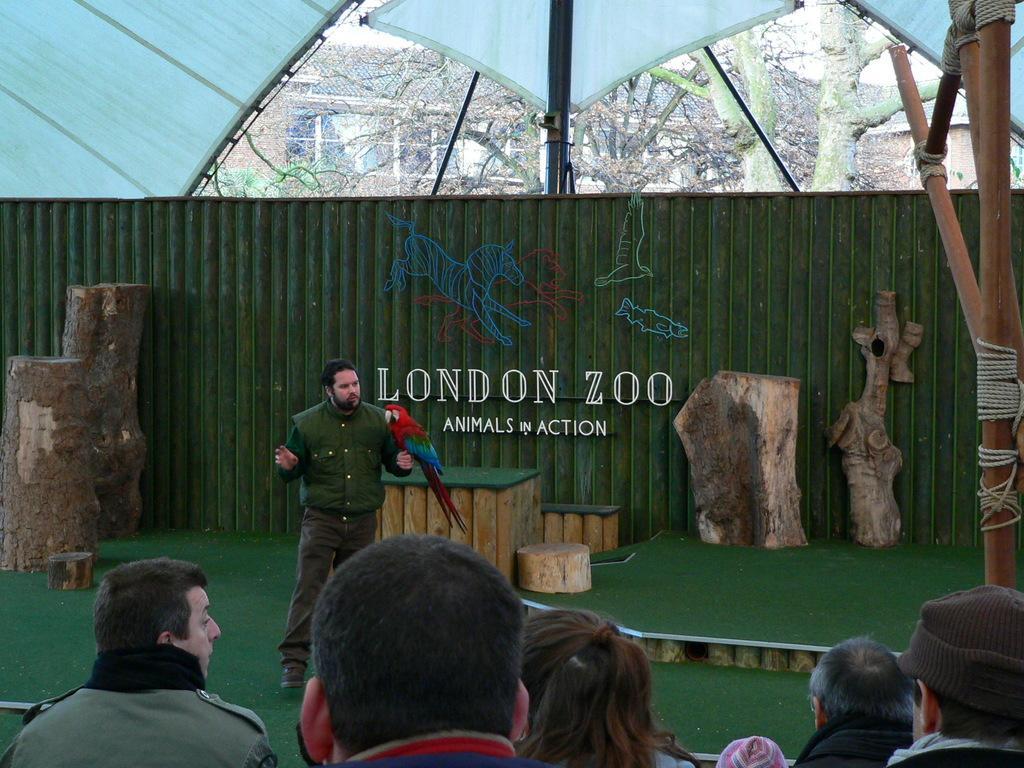How would you summarize this image in a sentence or two? This is an inside view of a shed and here we can see a person standing and holding a bird and we can see logs, people and there is some text and some images on the board. On the right, there is a stand and we can see ropes tied to it. In the background, there are trees and buildings and at the top, there is a roof. 